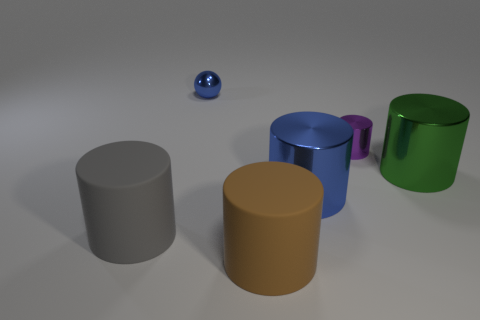Subtract 2 cylinders. How many cylinders are left? 3 Subtract all gray cylinders. How many cylinders are left? 4 Subtract all large blue cylinders. How many cylinders are left? 4 Subtract all red cylinders. Subtract all cyan balls. How many cylinders are left? 5 Add 2 metallic objects. How many objects exist? 8 Subtract all spheres. How many objects are left? 5 Subtract 1 green cylinders. How many objects are left? 5 Subtract all small gray shiny balls. Subtract all small purple metallic cylinders. How many objects are left? 5 Add 5 small cylinders. How many small cylinders are left? 6 Add 3 big brown objects. How many big brown objects exist? 4 